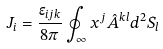<formula> <loc_0><loc_0><loc_500><loc_500>J _ { i } = \frac { \epsilon _ { i j k } } { 8 \pi } \oint _ { \infty } x ^ { j } \hat { A } ^ { k l } d ^ { 2 } S _ { l }</formula> 